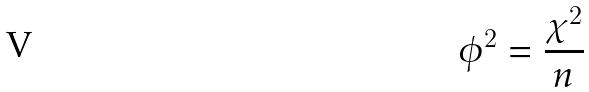Convert formula to latex. <formula><loc_0><loc_0><loc_500><loc_500>\phi ^ { 2 } = \frac { \chi ^ { 2 } } { n }</formula> 